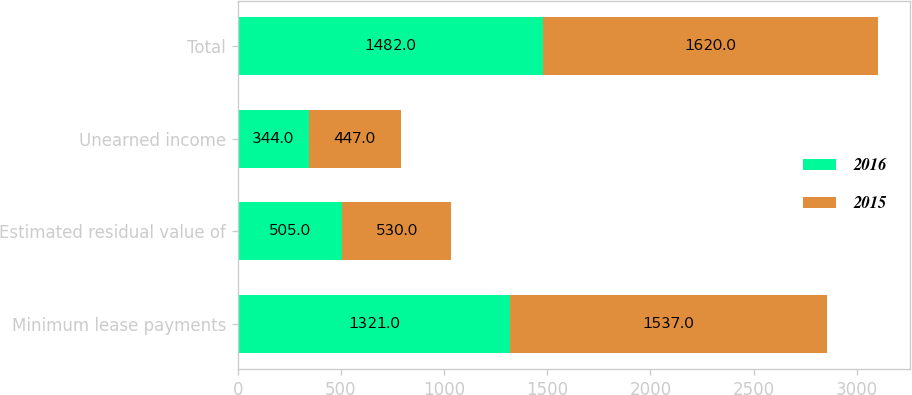<chart> <loc_0><loc_0><loc_500><loc_500><stacked_bar_chart><ecel><fcel>Minimum lease payments<fcel>Estimated residual value of<fcel>Unearned income<fcel>Total<nl><fcel>2016<fcel>1321<fcel>505<fcel>344<fcel>1482<nl><fcel>2015<fcel>1537<fcel>530<fcel>447<fcel>1620<nl></chart> 